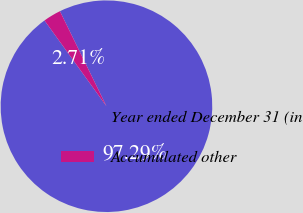Convert chart. <chart><loc_0><loc_0><loc_500><loc_500><pie_chart><fcel>Year ended December 31 (in<fcel>Accumulated other<nl><fcel>97.29%<fcel>2.71%<nl></chart> 